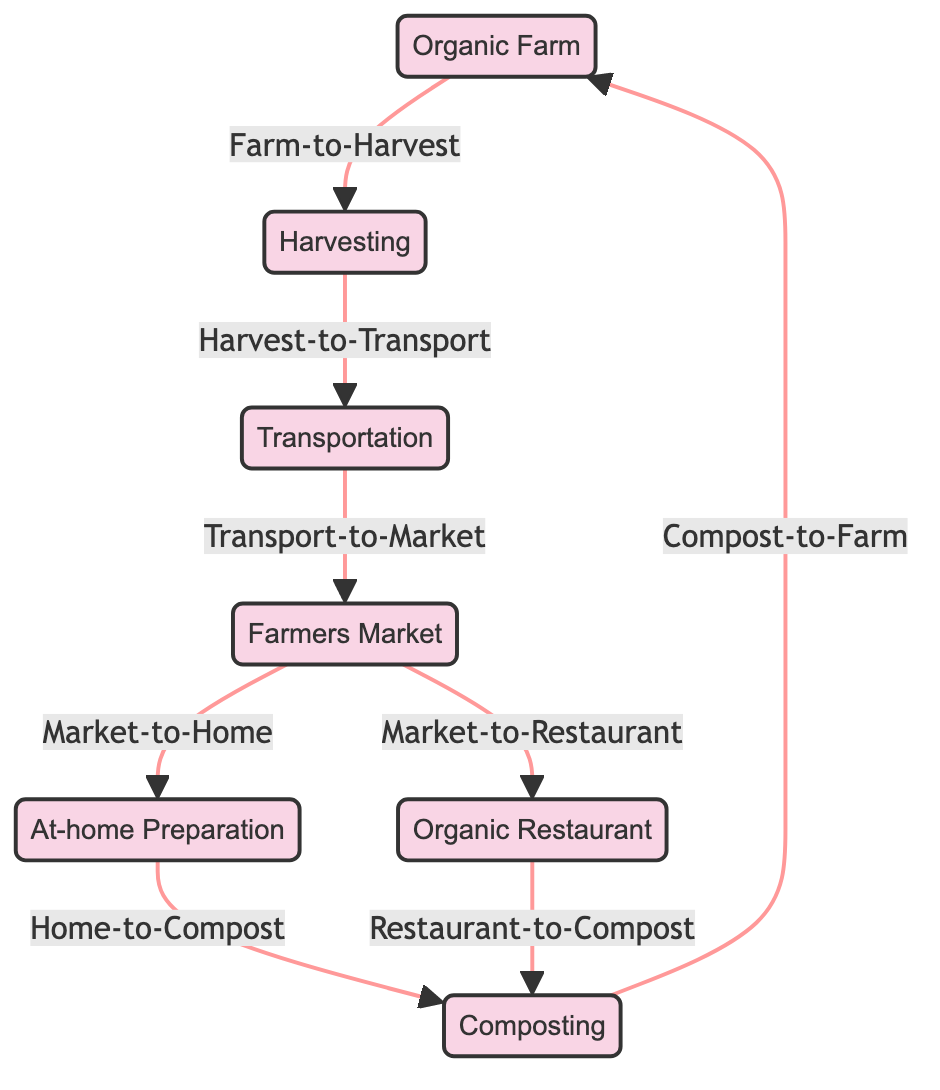What is the first node in the flow? The first node in the flowchart indicates the starting point of the food chain, which is the "Organic Farm." This is identified as the source where the organic produce originates before any other processes like harvesting occur.
Answer: Organic Farm How many nodes are in the diagram? To determine the number of nodes, one must count each distinct node shown in the diagram. There are seven nodes: Organic Farm, Harvesting, Transportation, Farmers Market, At-home Preparation, Organic Restaurant, and Composting.
Answer: Seven What follows after harvesting? Following the "Harvesting" node, the next step in the process is "Transportation." This connection indicates that once produce is harvested, it must be transported to the market for sale and consumption.
Answer: Transportation From where does composting return to? The "Composting" node returns to "Organic Farm," indicating that the organic compost created from waste products goes back to nourish and support the farm, facilitating the cycle of growing organic produce again.
Answer: Organic Farm Which node leads to both home preparation and restaurant? The node that directs to both "At-home Preparation" and "Organic Restaurant" is "Farmers Market." This indicates that produce from the market can be either taken home for personal preparation or purchased by restaurants for cooking.
Answer: Farmers Market What is one outcome of the at-home preparation? The outcome of "At-home Preparation" is "Composting." This shows that any organic waste generated from meal preparation at home is intended to be composted, supporting the cycle.
Answer: Composting Which two nodes are responsible for contributing to composting? The two nodes that contribute to "Composting" are "At-home Preparation" and "Organic Restaurant." Both nodes signify the end point of waste recycling from consumers and restaurants, respectively.
Answer: At-home Preparation and Organic Restaurant How do transportation and farmers market relate? "Transportation" leads directly to "Farmers Market." This connection illustrates that the transportation phase is essential for getting the harvested produce to markets where it can be sold.
Answer: Transportation leads to Farmers Market What type of restaurant is featured in this diagram? The diagram specifically mentions "Organic Restaurant," signifying a place that exclusively uses organic produce sourced from the farm chain illustrated.
Answer: Organic Restaurant 